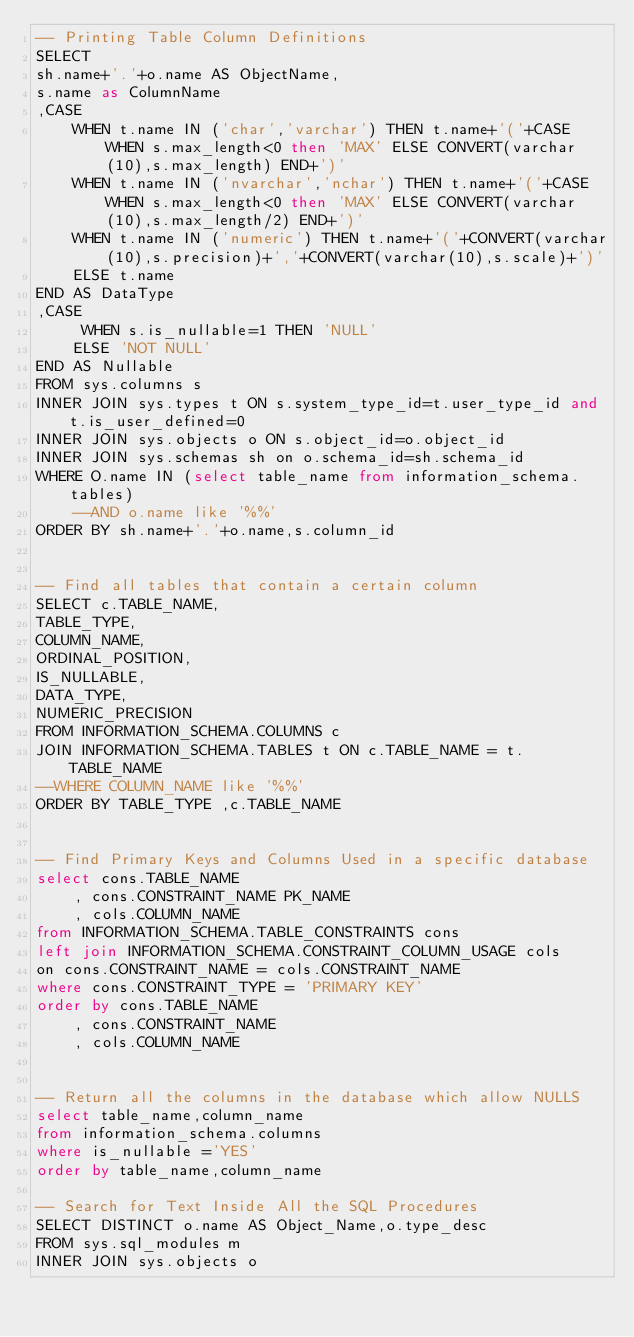Convert code to text. <code><loc_0><loc_0><loc_500><loc_500><_SQL_>-- Printing Table Column Definitions
SELECT
sh.name+'.'+o.name AS ObjectName,
s.name as ColumnName
,CASE
    WHEN t.name IN ('char','varchar') THEN t.name+'('+CASE WHEN s.max_length<0 then 'MAX' ELSE CONVERT(varchar(10),s.max_length) END+')'
    WHEN t.name IN ('nvarchar','nchar') THEN t.name+'('+CASE WHEN s.max_length<0 then 'MAX' ELSE CONVERT(varchar(10),s.max_length/2) END+')'
    WHEN t.name IN ('numeric') THEN t.name+'('+CONVERT(varchar(10),s.precision)+','+CONVERT(varchar(10),s.scale)+')'
    ELSE t.name
END AS DataType
,CASE
     WHEN s.is_nullable=1 THEN 'NULL'
    ELSE 'NOT NULL'
END AS Nullable       
FROM sys.columns s
INNER JOIN sys.types t ON s.system_type_id=t.user_type_id and t.is_user_defined=0
INNER JOIN sys.objects o ON s.object_id=o.object_id
INNER JOIN sys.schemas sh on o.schema_id=sh.schema_id
WHERE O.name IN (select table_name from information_schema.tables) 
	--AND o.name like '%%'
ORDER BY sh.name+'.'+o.name,s.column_id


-- Find all tables that contain a certain column
SELECT c.TABLE_NAME,
TABLE_TYPE,
COLUMN_NAME,
ORDINAL_POSITION,
IS_NULLABLE,
DATA_TYPE,
NUMERIC_PRECISION
FROM INFORMATION_SCHEMA.COLUMNS c
JOIN INFORMATION_SCHEMA.TABLES t ON c.TABLE_NAME = t.TABLE_NAME
--WHERE COLUMN_NAME like '%%'
ORDER BY TABLE_TYPE ,c.TABLE_NAME


-- Find Primary Keys and Columns Used in a specific database
select cons.TABLE_NAME
    , cons.CONSTRAINT_NAME PK_NAME
    , cols.COLUMN_NAME
from INFORMATION_SCHEMA.TABLE_CONSTRAINTS cons
left join INFORMATION_SCHEMA.CONSTRAINT_COLUMN_USAGE cols
on cons.CONSTRAINT_NAME = cols.CONSTRAINT_NAME
where cons.CONSTRAINT_TYPE = 'PRIMARY KEY'
order by cons.TABLE_NAME
    , cons.CONSTRAINT_NAME
    , cols.COLUMN_NAME


-- Return all the columns in the database which allow NULLS
select table_name,column_name
from information_schema.columns
where is_nullable ='YES'
order by table_name,column_name

-- Search for Text Inside All the SQL Procedures
SELECT DISTINCT o.name AS Object_Name,o.type_desc
FROM sys.sql_modules m
INNER JOIN sys.objects o</code> 